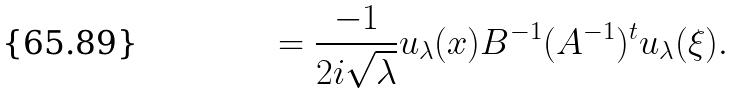<formula> <loc_0><loc_0><loc_500><loc_500>= \frac { - 1 } { 2 i \sqrt { \lambda } } u _ { \lambda } ( x ) B ^ { - 1 } ( A ^ { - 1 } ) ^ { t } u _ { \lambda } ( \xi ) .</formula> 